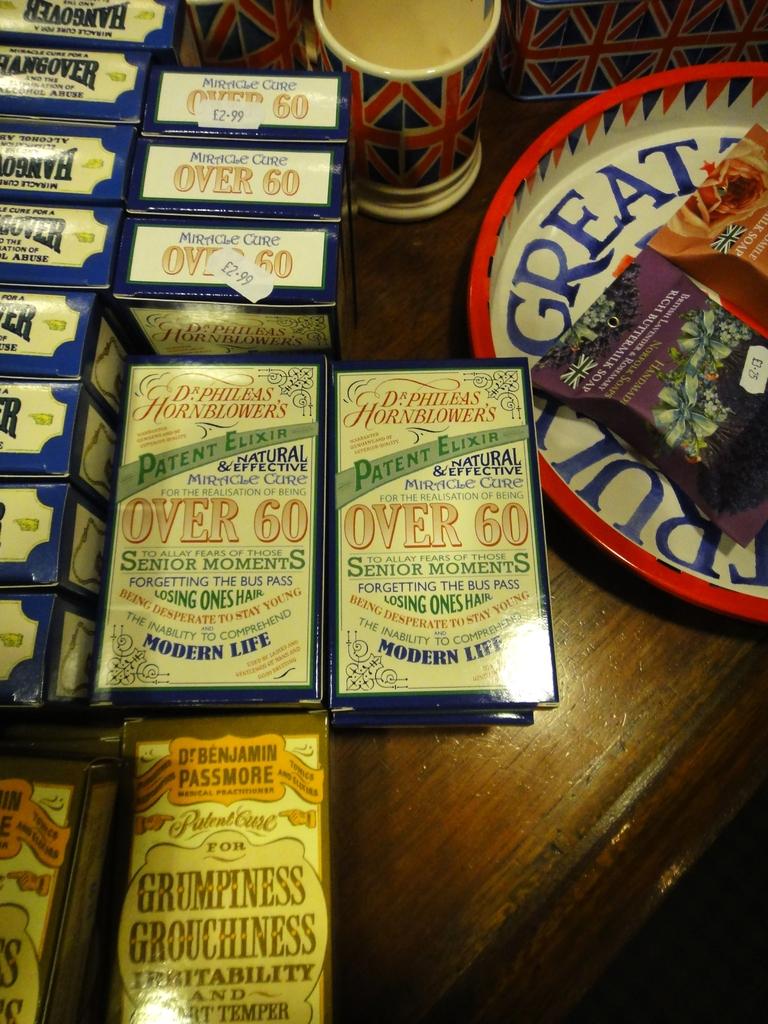Are these elixirs?
Keep it short and to the point. Yes. 